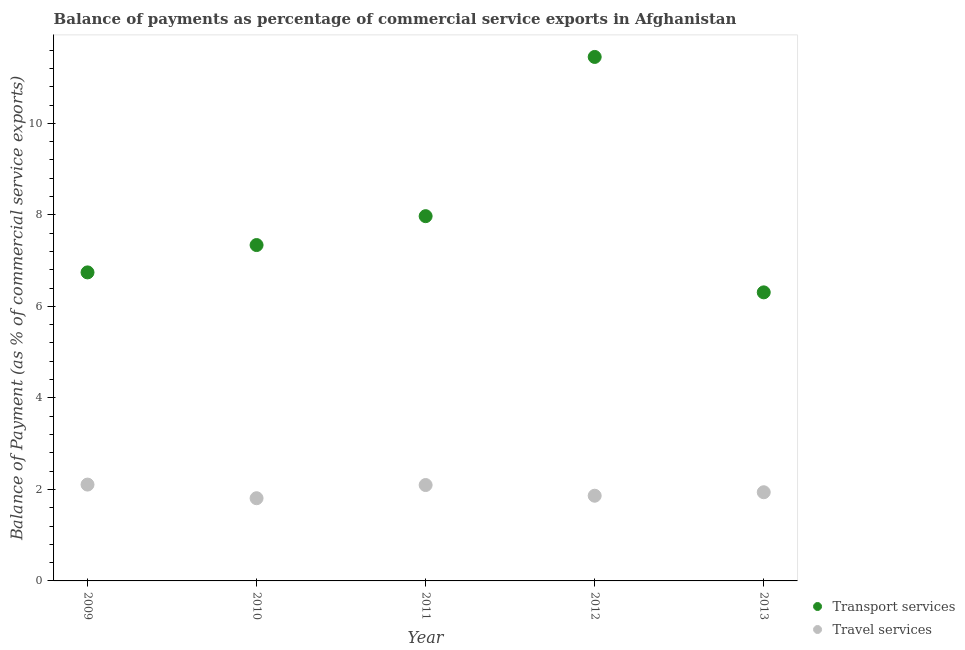Is the number of dotlines equal to the number of legend labels?
Keep it short and to the point. Yes. What is the balance of payments of travel services in 2011?
Provide a succinct answer. 2.1. Across all years, what is the maximum balance of payments of transport services?
Provide a short and direct response. 11.45. Across all years, what is the minimum balance of payments of travel services?
Give a very brief answer. 1.81. In which year was the balance of payments of travel services minimum?
Ensure brevity in your answer.  2010. What is the total balance of payments of transport services in the graph?
Your answer should be compact. 39.81. What is the difference between the balance of payments of travel services in 2011 and that in 2013?
Your response must be concise. 0.16. What is the difference between the balance of payments of transport services in 2010 and the balance of payments of travel services in 2012?
Offer a terse response. 5.48. What is the average balance of payments of travel services per year?
Provide a short and direct response. 1.96. In the year 2011, what is the difference between the balance of payments of travel services and balance of payments of transport services?
Your response must be concise. -5.88. What is the ratio of the balance of payments of transport services in 2010 to that in 2012?
Offer a terse response. 0.64. Is the balance of payments of travel services in 2011 less than that in 2012?
Your answer should be compact. No. What is the difference between the highest and the second highest balance of payments of travel services?
Your answer should be compact. 0.01. What is the difference between the highest and the lowest balance of payments of transport services?
Keep it short and to the point. 5.14. In how many years, is the balance of payments of transport services greater than the average balance of payments of transport services taken over all years?
Keep it short and to the point. 2. Is the sum of the balance of payments of transport services in 2009 and 2013 greater than the maximum balance of payments of travel services across all years?
Your response must be concise. Yes. Is the balance of payments of transport services strictly greater than the balance of payments of travel services over the years?
Ensure brevity in your answer.  Yes. Is the balance of payments of transport services strictly less than the balance of payments of travel services over the years?
Make the answer very short. No. How many dotlines are there?
Offer a very short reply. 2. What is the difference between two consecutive major ticks on the Y-axis?
Give a very brief answer. 2. Are the values on the major ticks of Y-axis written in scientific E-notation?
Your answer should be compact. No. Does the graph contain any zero values?
Offer a terse response. No. Does the graph contain grids?
Give a very brief answer. No. What is the title of the graph?
Keep it short and to the point. Balance of payments as percentage of commercial service exports in Afghanistan. What is the label or title of the Y-axis?
Your answer should be compact. Balance of Payment (as % of commercial service exports). What is the Balance of Payment (as % of commercial service exports) of Transport services in 2009?
Provide a short and direct response. 6.74. What is the Balance of Payment (as % of commercial service exports) in Travel services in 2009?
Your answer should be compact. 2.11. What is the Balance of Payment (as % of commercial service exports) in Transport services in 2010?
Your response must be concise. 7.34. What is the Balance of Payment (as % of commercial service exports) of Travel services in 2010?
Your answer should be compact. 1.81. What is the Balance of Payment (as % of commercial service exports) of Transport services in 2011?
Give a very brief answer. 7.97. What is the Balance of Payment (as % of commercial service exports) of Travel services in 2011?
Provide a short and direct response. 2.1. What is the Balance of Payment (as % of commercial service exports) in Transport services in 2012?
Give a very brief answer. 11.45. What is the Balance of Payment (as % of commercial service exports) of Travel services in 2012?
Offer a terse response. 1.86. What is the Balance of Payment (as % of commercial service exports) in Transport services in 2013?
Provide a succinct answer. 6.31. What is the Balance of Payment (as % of commercial service exports) of Travel services in 2013?
Provide a succinct answer. 1.94. Across all years, what is the maximum Balance of Payment (as % of commercial service exports) in Transport services?
Keep it short and to the point. 11.45. Across all years, what is the maximum Balance of Payment (as % of commercial service exports) of Travel services?
Offer a terse response. 2.11. Across all years, what is the minimum Balance of Payment (as % of commercial service exports) of Transport services?
Give a very brief answer. 6.31. Across all years, what is the minimum Balance of Payment (as % of commercial service exports) in Travel services?
Ensure brevity in your answer.  1.81. What is the total Balance of Payment (as % of commercial service exports) in Transport services in the graph?
Provide a succinct answer. 39.81. What is the total Balance of Payment (as % of commercial service exports) of Travel services in the graph?
Your response must be concise. 9.81. What is the difference between the Balance of Payment (as % of commercial service exports) in Transport services in 2009 and that in 2010?
Ensure brevity in your answer.  -0.6. What is the difference between the Balance of Payment (as % of commercial service exports) of Travel services in 2009 and that in 2010?
Give a very brief answer. 0.3. What is the difference between the Balance of Payment (as % of commercial service exports) in Transport services in 2009 and that in 2011?
Give a very brief answer. -1.23. What is the difference between the Balance of Payment (as % of commercial service exports) of Travel services in 2009 and that in 2011?
Ensure brevity in your answer.  0.01. What is the difference between the Balance of Payment (as % of commercial service exports) of Transport services in 2009 and that in 2012?
Make the answer very short. -4.71. What is the difference between the Balance of Payment (as % of commercial service exports) in Travel services in 2009 and that in 2012?
Your answer should be compact. 0.24. What is the difference between the Balance of Payment (as % of commercial service exports) of Transport services in 2009 and that in 2013?
Provide a short and direct response. 0.44. What is the difference between the Balance of Payment (as % of commercial service exports) in Travel services in 2009 and that in 2013?
Your answer should be very brief. 0.17. What is the difference between the Balance of Payment (as % of commercial service exports) in Transport services in 2010 and that in 2011?
Keep it short and to the point. -0.63. What is the difference between the Balance of Payment (as % of commercial service exports) of Travel services in 2010 and that in 2011?
Your answer should be compact. -0.29. What is the difference between the Balance of Payment (as % of commercial service exports) in Transport services in 2010 and that in 2012?
Ensure brevity in your answer.  -4.11. What is the difference between the Balance of Payment (as % of commercial service exports) of Travel services in 2010 and that in 2012?
Offer a very short reply. -0.05. What is the difference between the Balance of Payment (as % of commercial service exports) of Transport services in 2010 and that in 2013?
Offer a terse response. 1.03. What is the difference between the Balance of Payment (as % of commercial service exports) in Travel services in 2010 and that in 2013?
Offer a very short reply. -0.13. What is the difference between the Balance of Payment (as % of commercial service exports) of Transport services in 2011 and that in 2012?
Offer a terse response. -3.48. What is the difference between the Balance of Payment (as % of commercial service exports) of Travel services in 2011 and that in 2012?
Your response must be concise. 0.23. What is the difference between the Balance of Payment (as % of commercial service exports) in Transport services in 2011 and that in 2013?
Offer a very short reply. 1.67. What is the difference between the Balance of Payment (as % of commercial service exports) in Travel services in 2011 and that in 2013?
Ensure brevity in your answer.  0.16. What is the difference between the Balance of Payment (as % of commercial service exports) in Transport services in 2012 and that in 2013?
Provide a short and direct response. 5.14. What is the difference between the Balance of Payment (as % of commercial service exports) in Travel services in 2012 and that in 2013?
Ensure brevity in your answer.  -0.08. What is the difference between the Balance of Payment (as % of commercial service exports) of Transport services in 2009 and the Balance of Payment (as % of commercial service exports) of Travel services in 2010?
Your answer should be very brief. 4.93. What is the difference between the Balance of Payment (as % of commercial service exports) in Transport services in 2009 and the Balance of Payment (as % of commercial service exports) in Travel services in 2011?
Offer a terse response. 4.65. What is the difference between the Balance of Payment (as % of commercial service exports) of Transport services in 2009 and the Balance of Payment (as % of commercial service exports) of Travel services in 2012?
Provide a short and direct response. 4.88. What is the difference between the Balance of Payment (as % of commercial service exports) of Transport services in 2009 and the Balance of Payment (as % of commercial service exports) of Travel services in 2013?
Offer a very short reply. 4.8. What is the difference between the Balance of Payment (as % of commercial service exports) of Transport services in 2010 and the Balance of Payment (as % of commercial service exports) of Travel services in 2011?
Provide a succinct answer. 5.24. What is the difference between the Balance of Payment (as % of commercial service exports) in Transport services in 2010 and the Balance of Payment (as % of commercial service exports) in Travel services in 2012?
Provide a succinct answer. 5.48. What is the difference between the Balance of Payment (as % of commercial service exports) in Transport services in 2010 and the Balance of Payment (as % of commercial service exports) in Travel services in 2013?
Provide a short and direct response. 5.4. What is the difference between the Balance of Payment (as % of commercial service exports) in Transport services in 2011 and the Balance of Payment (as % of commercial service exports) in Travel services in 2012?
Keep it short and to the point. 6.11. What is the difference between the Balance of Payment (as % of commercial service exports) of Transport services in 2011 and the Balance of Payment (as % of commercial service exports) of Travel services in 2013?
Make the answer very short. 6.03. What is the difference between the Balance of Payment (as % of commercial service exports) in Transport services in 2012 and the Balance of Payment (as % of commercial service exports) in Travel services in 2013?
Offer a terse response. 9.51. What is the average Balance of Payment (as % of commercial service exports) of Transport services per year?
Offer a terse response. 7.96. What is the average Balance of Payment (as % of commercial service exports) in Travel services per year?
Your response must be concise. 1.96. In the year 2009, what is the difference between the Balance of Payment (as % of commercial service exports) in Transport services and Balance of Payment (as % of commercial service exports) in Travel services?
Ensure brevity in your answer.  4.64. In the year 2010, what is the difference between the Balance of Payment (as % of commercial service exports) of Transport services and Balance of Payment (as % of commercial service exports) of Travel services?
Provide a succinct answer. 5.53. In the year 2011, what is the difference between the Balance of Payment (as % of commercial service exports) of Transport services and Balance of Payment (as % of commercial service exports) of Travel services?
Provide a succinct answer. 5.88. In the year 2012, what is the difference between the Balance of Payment (as % of commercial service exports) of Transport services and Balance of Payment (as % of commercial service exports) of Travel services?
Offer a terse response. 9.59. In the year 2013, what is the difference between the Balance of Payment (as % of commercial service exports) of Transport services and Balance of Payment (as % of commercial service exports) of Travel services?
Provide a succinct answer. 4.37. What is the ratio of the Balance of Payment (as % of commercial service exports) in Transport services in 2009 to that in 2010?
Provide a short and direct response. 0.92. What is the ratio of the Balance of Payment (as % of commercial service exports) in Travel services in 2009 to that in 2010?
Your answer should be compact. 1.16. What is the ratio of the Balance of Payment (as % of commercial service exports) of Transport services in 2009 to that in 2011?
Your answer should be very brief. 0.85. What is the ratio of the Balance of Payment (as % of commercial service exports) in Travel services in 2009 to that in 2011?
Make the answer very short. 1. What is the ratio of the Balance of Payment (as % of commercial service exports) in Transport services in 2009 to that in 2012?
Offer a terse response. 0.59. What is the ratio of the Balance of Payment (as % of commercial service exports) of Travel services in 2009 to that in 2012?
Ensure brevity in your answer.  1.13. What is the ratio of the Balance of Payment (as % of commercial service exports) of Transport services in 2009 to that in 2013?
Offer a very short reply. 1.07. What is the ratio of the Balance of Payment (as % of commercial service exports) of Travel services in 2009 to that in 2013?
Your response must be concise. 1.09. What is the ratio of the Balance of Payment (as % of commercial service exports) in Transport services in 2010 to that in 2011?
Provide a succinct answer. 0.92. What is the ratio of the Balance of Payment (as % of commercial service exports) in Travel services in 2010 to that in 2011?
Make the answer very short. 0.86. What is the ratio of the Balance of Payment (as % of commercial service exports) of Transport services in 2010 to that in 2012?
Offer a terse response. 0.64. What is the ratio of the Balance of Payment (as % of commercial service exports) of Travel services in 2010 to that in 2012?
Ensure brevity in your answer.  0.97. What is the ratio of the Balance of Payment (as % of commercial service exports) of Transport services in 2010 to that in 2013?
Provide a succinct answer. 1.16. What is the ratio of the Balance of Payment (as % of commercial service exports) in Travel services in 2010 to that in 2013?
Make the answer very short. 0.93. What is the ratio of the Balance of Payment (as % of commercial service exports) in Transport services in 2011 to that in 2012?
Your answer should be very brief. 0.7. What is the ratio of the Balance of Payment (as % of commercial service exports) in Travel services in 2011 to that in 2012?
Ensure brevity in your answer.  1.13. What is the ratio of the Balance of Payment (as % of commercial service exports) of Transport services in 2011 to that in 2013?
Provide a succinct answer. 1.26. What is the ratio of the Balance of Payment (as % of commercial service exports) in Travel services in 2011 to that in 2013?
Provide a short and direct response. 1.08. What is the ratio of the Balance of Payment (as % of commercial service exports) in Transport services in 2012 to that in 2013?
Your answer should be very brief. 1.82. What is the ratio of the Balance of Payment (as % of commercial service exports) in Travel services in 2012 to that in 2013?
Your answer should be very brief. 0.96. What is the difference between the highest and the second highest Balance of Payment (as % of commercial service exports) in Transport services?
Offer a terse response. 3.48. What is the difference between the highest and the second highest Balance of Payment (as % of commercial service exports) of Travel services?
Give a very brief answer. 0.01. What is the difference between the highest and the lowest Balance of Payment (as % of commercial service exports) in Transport services?
Keep it short and to the point. 5.14. What is the difference between the highest and the lowest Balance of Payment (as % of commercial service exports) of Travel services?
Give a very brief answer. 0.3. 